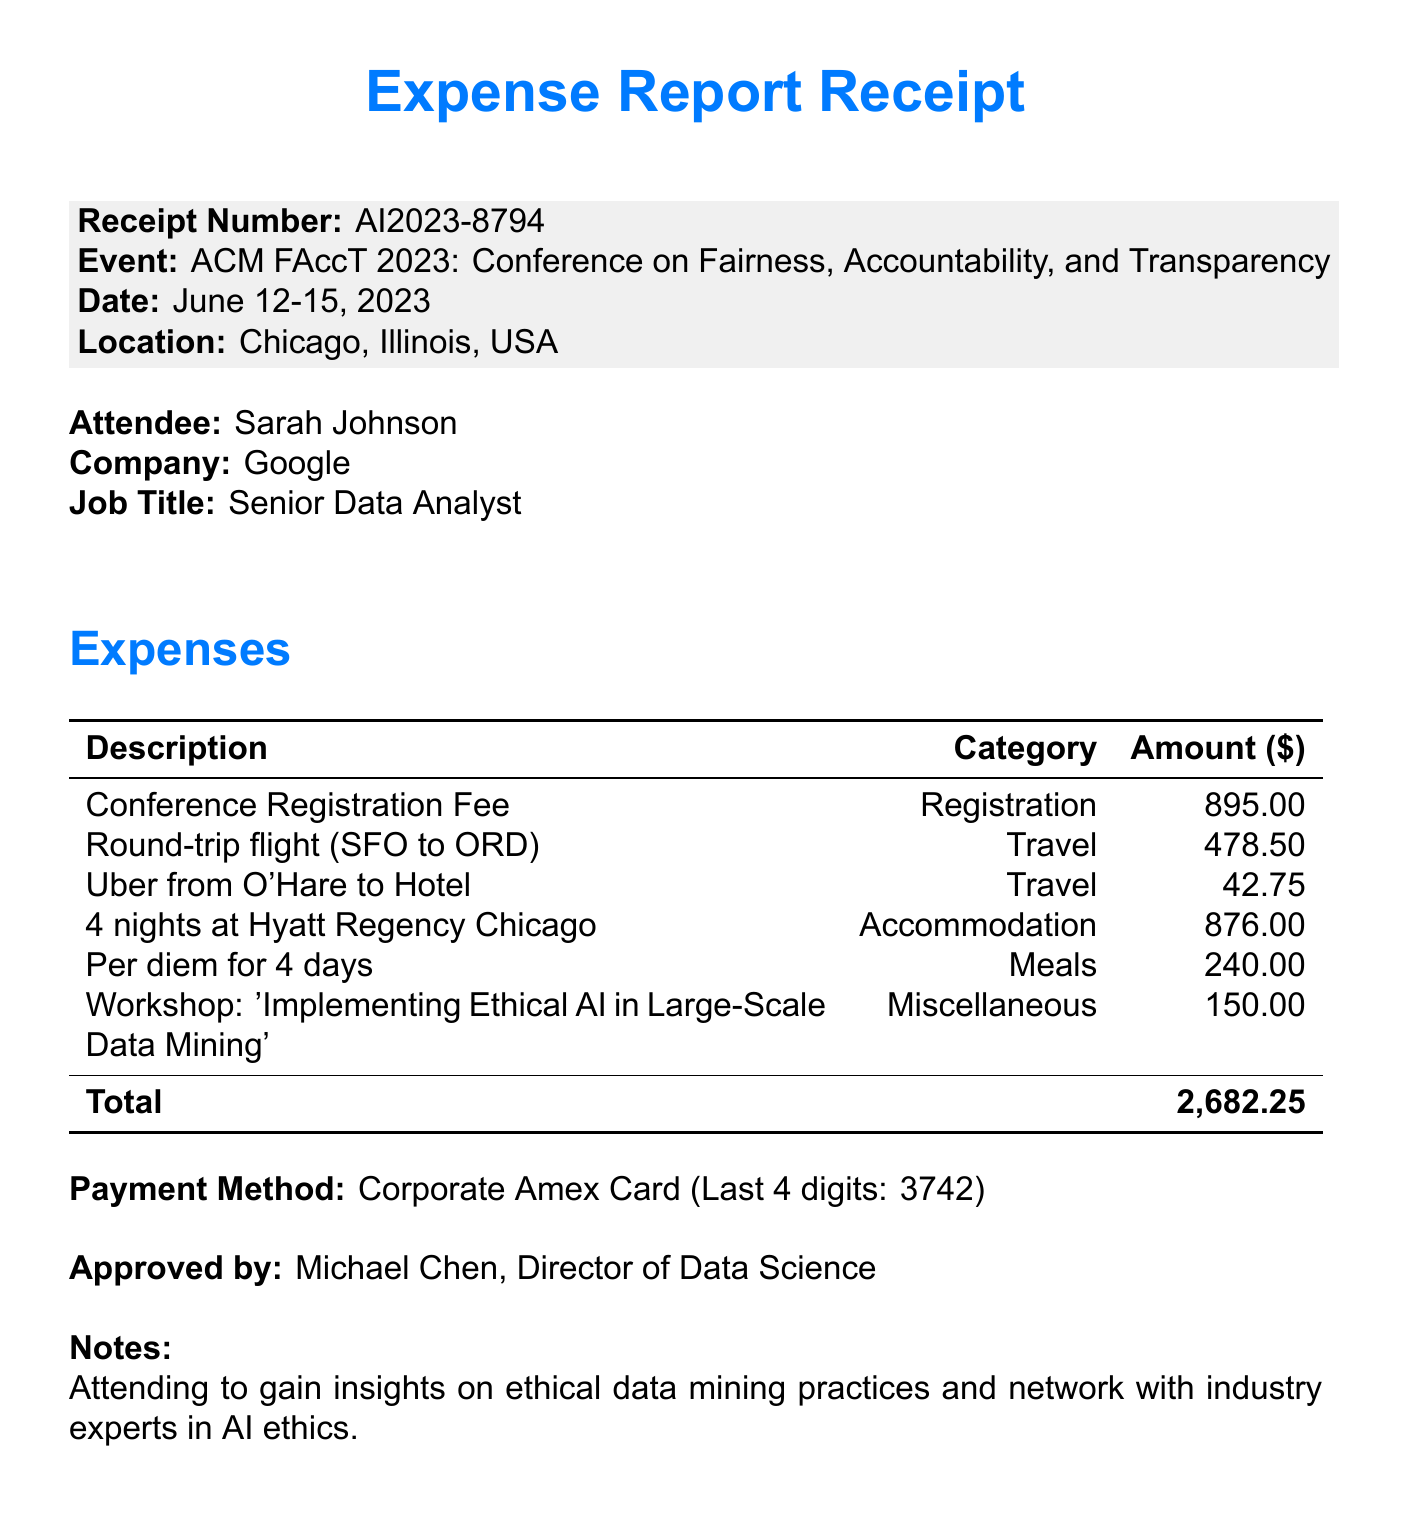What is the receipt number? The receipt number is explicitly mentioned in the document as a unique identifier for this expense report.
Answer: AI2023-8794 What is the attendee's job title? The document states the job title of the attendee, which signifies their role in the company.
Answer: Senior Data Analyst What are the total expenses amount? The document summarizes all expenses incurred during the event and presents a total amount, which is the sum of various individual expenses.
Answer: 2,682.25 Which hotel was used for accommodation? The document specifies the name of the hotel where the attendee stayed during the conference.
Answer: Hyatt Regency Chicago What category does the workshop expense belong to? The document categorizes each expense and specifies the category for the workshop expense incurred.
Answer: Miscellaneous How many nights were spent at the hotel? The expenses related to accommodation specify the duration of the stay in terms of nights.
Answer: 4 Who approved the expense report? The approver's name and title are indicated in the document.
Answer: Michael Chen What was the payment method used for expenses? The receipt mentions the method of payment used to cover the expenses reported.
Answer: Corporate Amex Card What event did the attendee participate in? The name of the conference event attended by the participant is clearly stated in the document.
Answer: ACM FAccT 2023: Conference on Fairness, Accountability, and Transparency 